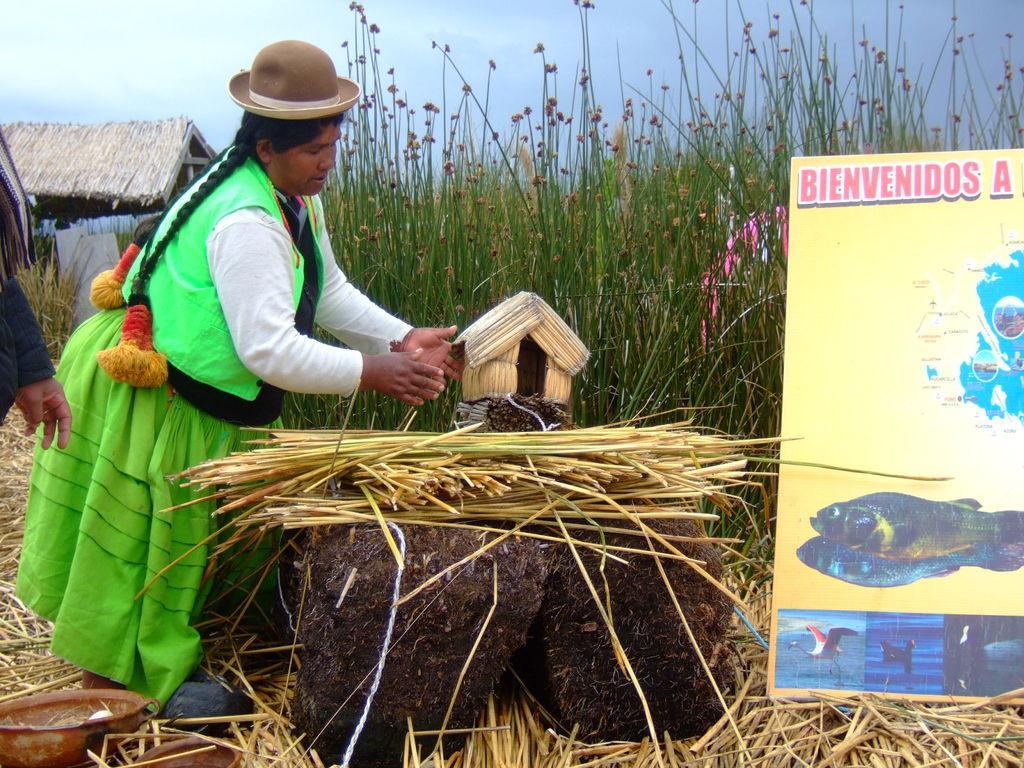Could you give a brief overview of what you see in this image? In this image there is a lady wearing hat on her head and she is standing on the surface of the dry grass, in front of her there is an object on which there is a toy house and grass are placed, there are few objects and a banner on the surface of the grass. In the background there is a hut, grass and the sky. 